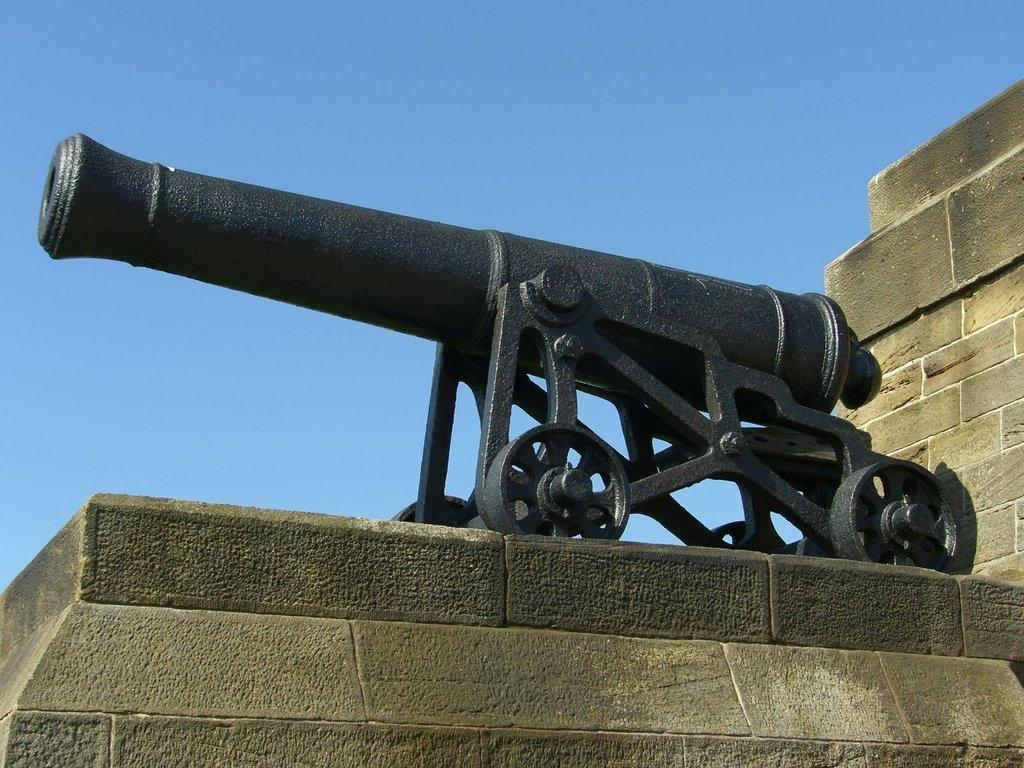What structure can be seen in the image? There is a wall in the image. What is placed on the wall? There is a cannon on the wall. What can be seen in the background of the image? The sky is visible in the background of the image. What type of jelly is being used to lubricate the cannon in the image? There is no jelly present in the image, nor is there any indication that the cannon is being lubricated. 